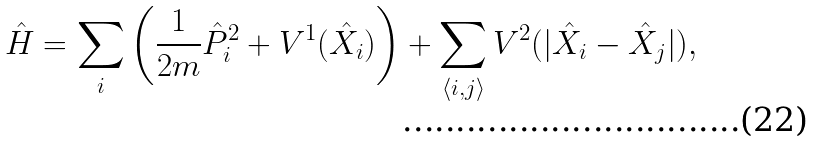Convert formula to latex. <formula><loc_0><loc_0><loc_500><loc_500>\hat { H } = \sum _ { i } \left ( \frac { 1 } { 2 m } \hat { P } _ { i } ^ { 2 } + V ^ { 1 } ( \hat { X } _ { i } ) \right ) + \sum _ { \langle i , j \rangle } V ^ { 2 } ( | \hat { X } _ { i } - \hat { X } _ { j } | ) ,</formula> 